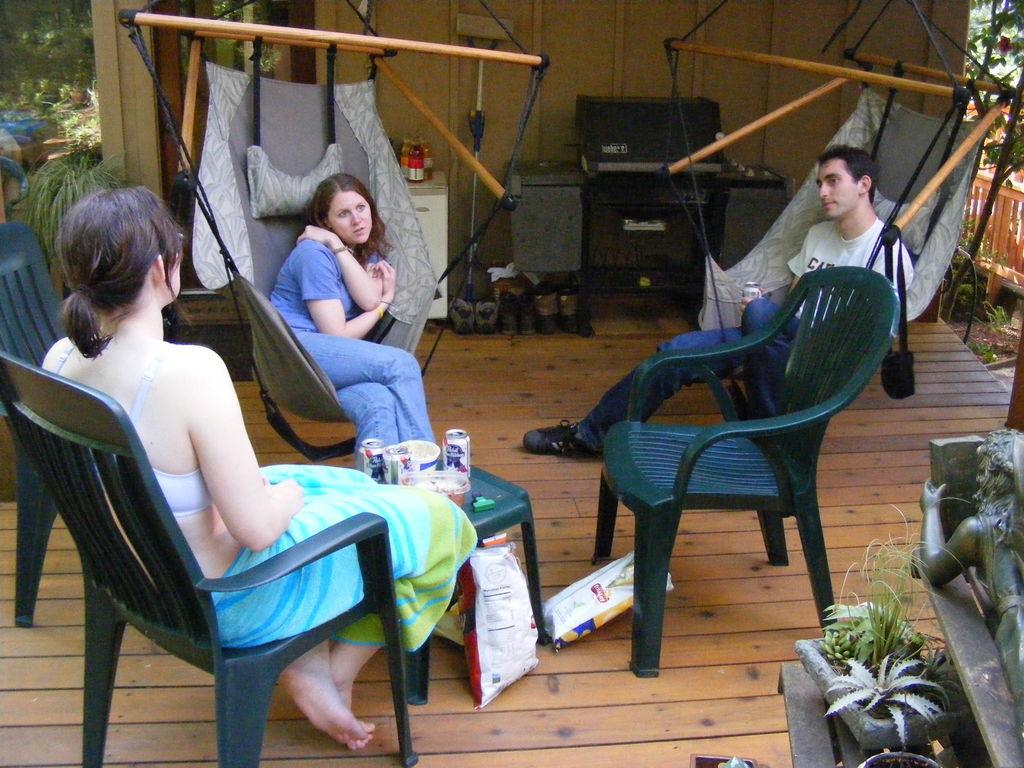Describe this image in one or two sentences. a person is sitting on a chair on the wooden floor. on front of her there is a plastic table on which there are tins. on the floor there are 2 packs. in front of that there are 2 people sitting. the person at the right is wearing a white t shirt and blue jeans. the person at the left is wearing blue t shirt and jeans. at the right there is a sculpture and plants. at the back there are boxes and shoes. at the left there are trees. at the right there is fencing and trees. 